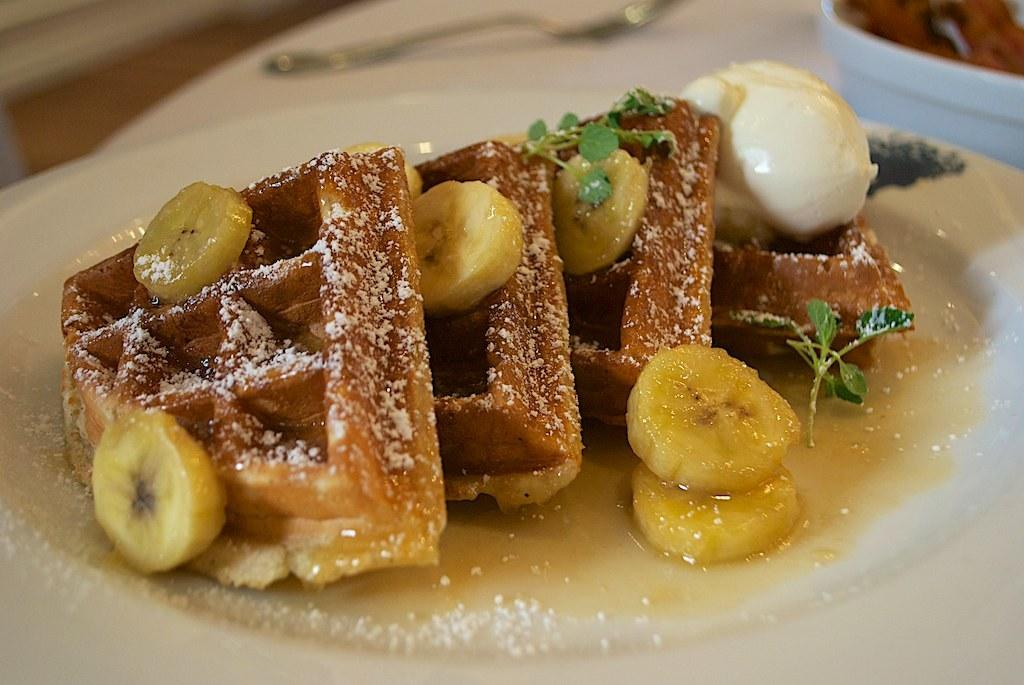What type of food item can be seen in the image? There is a food item in the image. How is the food item decorated? The food item is decorated with banana. What color is the plate on which the food item is placed? The food item is placed on a white color plate. Are there any leaves associated with the food item? Yes, the food item has leaves in the image. How does the fan help to increase the temperature in the image? There is no fan present in the image, so it cannot help to increase the temperature. 